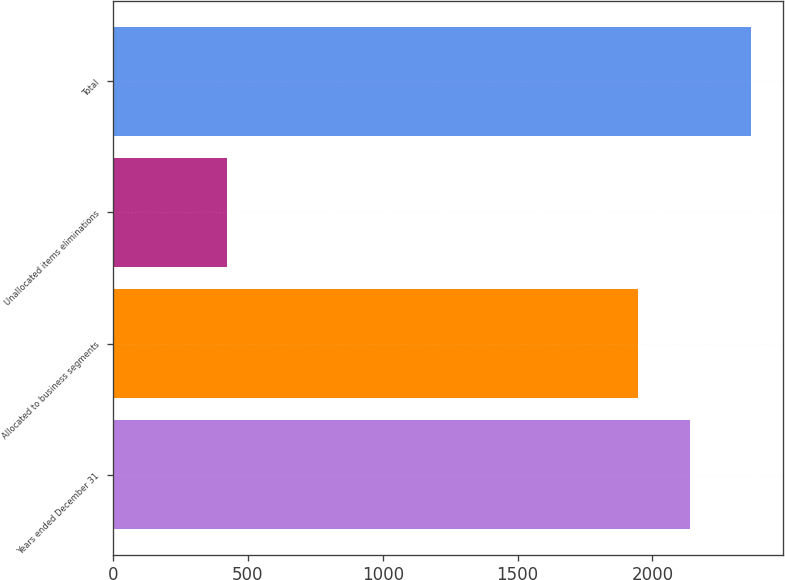Convert chart. <chart><loc_0><loc_0><loc_500><loc_500><bar_chart><fcel>Years ended December 31<fcel>Allocated to business segments<fcel>Unallocated items eliminations<fcel>Total<nl><fcel>2139.5<fcel>1945<fcel>421<fcel>2366<nl></chart> 